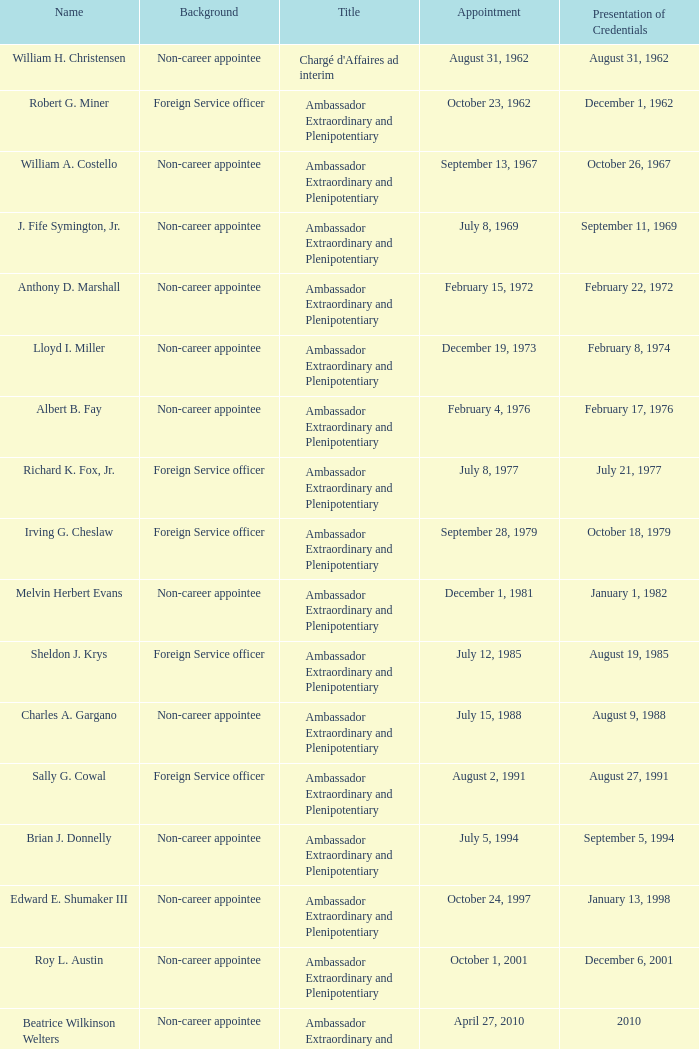Who presented their credentials at an unknown date? Margaret B. Diop. 